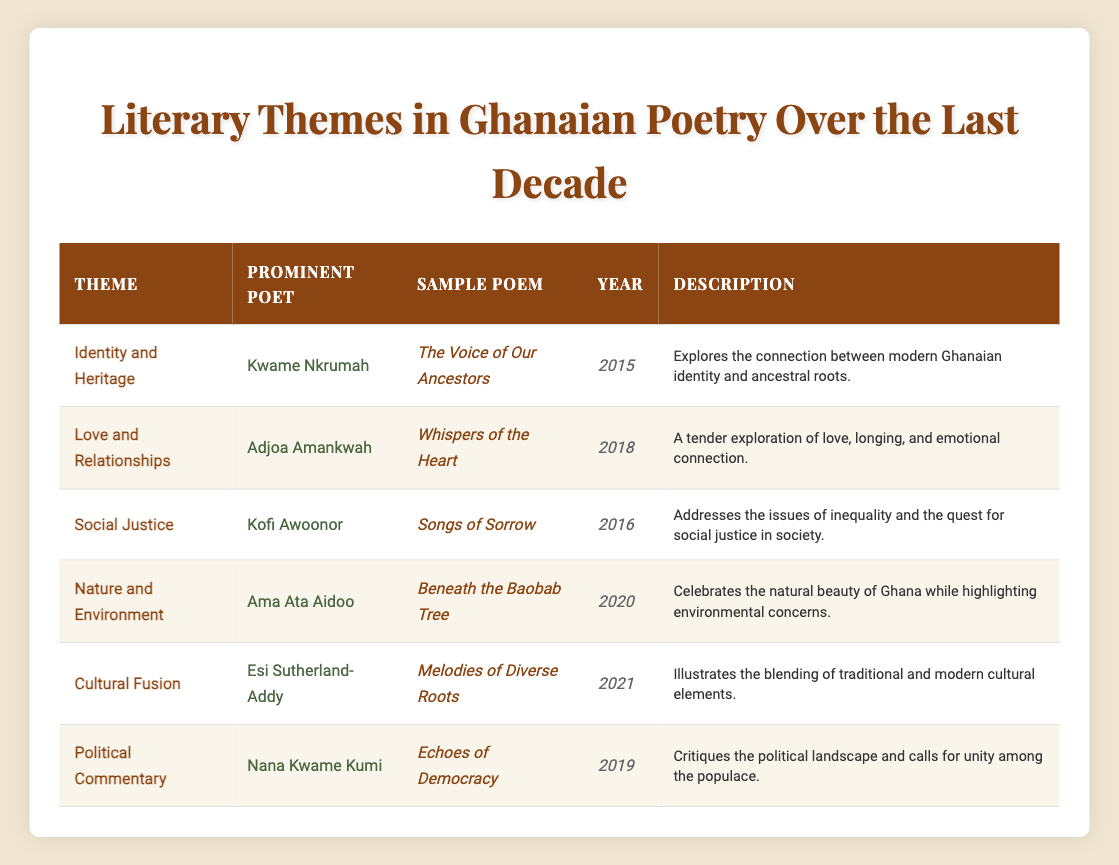What is the theme of the poem "The Voice of Our Ancestors"? In the table, "The Voice of Our Ancestors" is associated with the theme "Identity and Heritage".
Answer: Identity and Heritage Who is the prominent poet for the poem "Beneath the Baobab Tree"? The table indicates that "Beneath the Baobab Tree" is written by the prominent poet Ama Ata Aidoo.
Answer: Ama Ata Aidoo Is "Whispers of the Heart" a poem about social issues? The table does not list "Whispers of the Heart" under any social justice themes; it is instead about love and relationships, which indicates it is not focused on social issues.
Answer: No Which poem addresses the theme of cultural fusion? From the table, the poem that addresses cultural fusion is "Melodies of Diverse Roots", written by Esi Sutherland-Addy.
Answer: Melodies of Diverse Roots How many poems were published from 2015 to 2018? By reviewing the years listed in the table, "The Voice of Our Ancestors" (2015), "Songs of Sorrow" (2016), and "Whispers of the Heart" (2018) indicate that there are three poems published between 2015 and 2018.
Answer: 3 What is the latest year mentioned in the table? The latest year listed in the table under the "Year" column is 2021, as shown next to the poem "Melodies of Diverse Roots".
Answer: 2021 Which themes were explored in the same year, 2019? The table shows that only one theme was explored in 2019: "Political Commentary" with the poem "Echoes of Democracy" by Nana Kwame Kumi.
Answer: Political Commentary Did Kofi Awoonor write a poem related to love and relationships? According to the table, Kofi Awoonor is associated with the theme of social justice, and there is no indication that he wrote a poem on love and relationships.
Answer: No What is the primary focus of the poem "Songs of Sorrow"? The table describes "Songs of Sorrow" as addressing issues of inequality and the quest for social justice, indicating its primary focus.
Answer: Social justice issues 